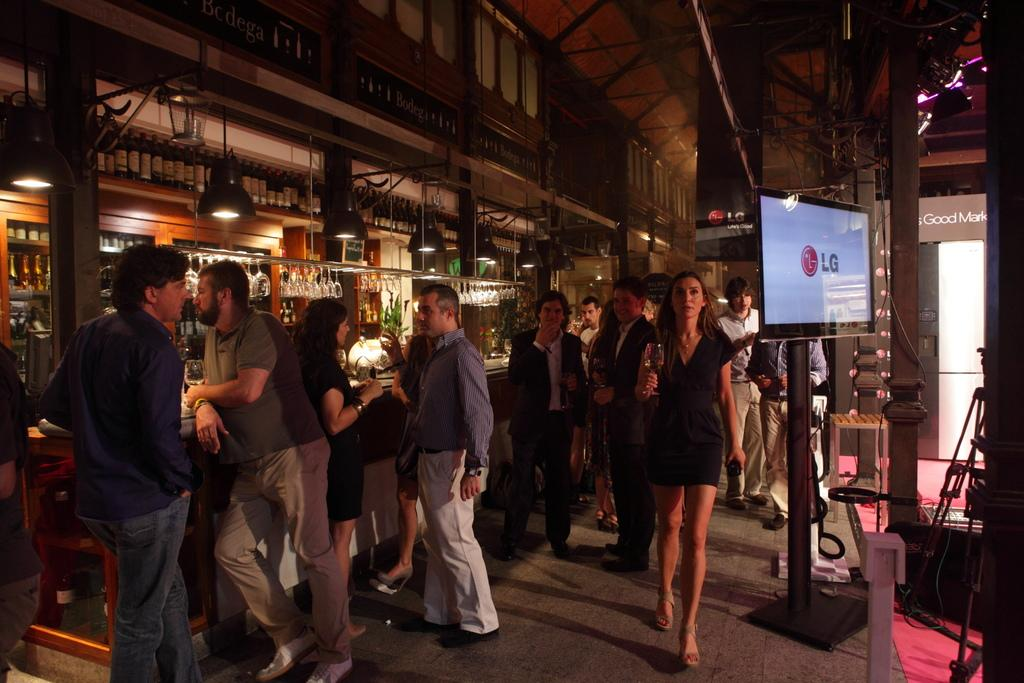What is the main subject of the image? There is a beautiful woman in the image. What is the woman doing in the image? The woman is walking on the right side of the image. What is the woman wearing in the image? The woman is wearing a dress. What electronic device is present in the image? There is a television in the image. Where is the television located in relation to the woman? The television is beside the woman. What type of establishment can be seen in the image? There is a bar in the image. Where is the bar located in the image? The bar is on the left side of the image. Are there any people near the bar? Yes, there are people standing near the bar. What is the price of the pet that the woman is holding in the image? There is no pet present in the image, so there is no price to consider. 